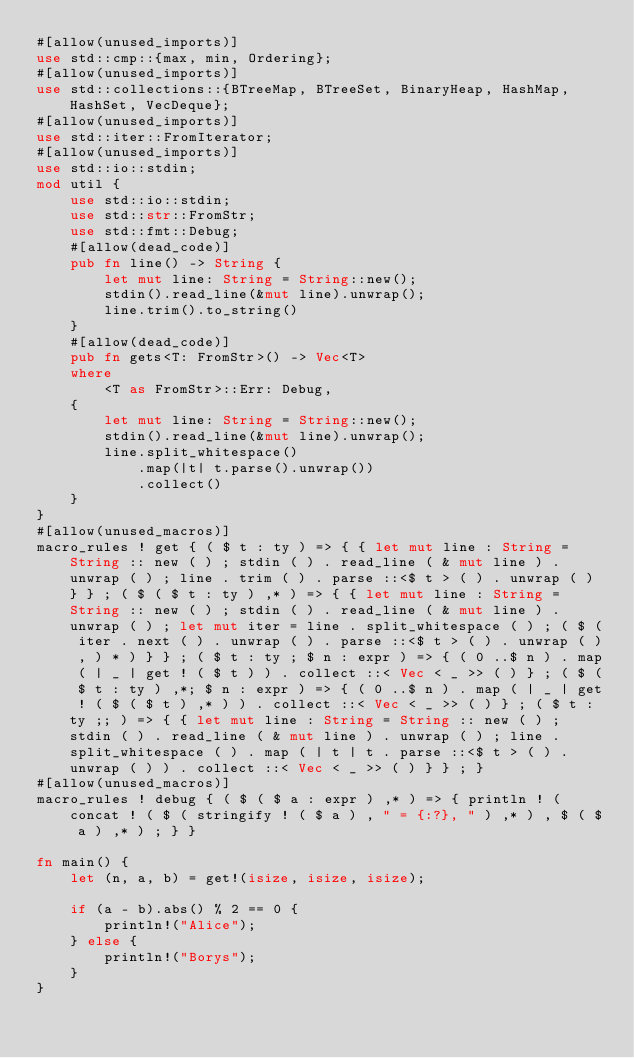Convert code to text. <code><loc_0><loc_0><loc_500><loc_500><_Rust_>#[allow(unused_imports)]
use std::cmp::{max, min, Ordering};
#[allow(unused_imports)]
use std::collections::{BTreeMap, BTreeSet, BinaryHeap, HashMap, HashSet, VecDeque};
#[allow(unused_imports)]
use std::iter::FromIterator;
#[allow(unused_imports)]
use std::io::stdin;
mod util {
    use std::io::stdin;
    use std::str::FromStr;
    use std::fmt::Debug;
    #[allow(dead_code)]
    pub fn line() -> String {
        let mut line: String = String::new();
        stdin().read_line(&mut line).unwrap();
        line.trim().to_string()
    }
    #[allow(dead_code)]
    pub fn gets<T: FromStr>() -> Vec<T>
    where
        <T as FromStr>::Err: Debug,
    {
        let mut line: String = String::new();
        stdin().read_line(&mut line).unwrap();
        line.split_whitespace()
            .map(|t| t.parse().unwrap())
            .collect()
    }
}
#[allow(unused_macros)]
macro_rules ! get { ( $ t : ty ) => { { let mut line : String = String :: new ( ) ; stdin ( ) . read_line ( & mut line ) . unwrap ( ) ; line . trim ( ) . parse ::<$ t > ( ) . unwrap ( ) } } ; ( $ ( $ t : ty ) ,* ) => { { let mut line : String = String :: new ( ) ; stdin ( ) . read_line ( & mut line ) . unwrap ( ) ; let mut iter = line . split_whitespace ( ) ; ( $ ( iter . next ( ) . unwrap ( ) . parse ::<$ t > ( ) . unwrap ( ) , ) * ) } } ; ( $ t : ty ; $ n : expr ) => { ( 0 ..$ n ) . map ( | _ | get ! ( $ t ) ) . collect ::< Vec < _ >> ( ) } ; ( $ ( $ t : ty ) ,*; $ n : expr ) => { ( 0 ..$ n ) . map ( | _ | get ! ( $ ( $ t ) ,* ) ) . collect ::< Vec < _ >> ( ) } ; ( $ t : ty ;; ) => { { let mut line : String = String :: new ( ) ; stdin ( ) . read_line ( & mut line ) . unwrap ( ) ; line . split_whitespace ( ) . map ( | t | t . parse ::<$ t > ( ) . unwrap ( ) ) . collect ::< Vec < _ >> ( ) } } ; }
#[allow(unused_macros)]
macro_rules ! debug { ( $ ( $ a : expr ) ,* ) => { println ! ( concat ! ( $ ( stringify ! ( $ a ) , " = {:?}, " ) ,* ) , $ ( $ a ) ,* ) ; } }

fn main() {
    let (n, a, b) = get!(isize, isize, isize);

    if (a - b).abs() % 2 == 0 {
        println!("Alice");
    } else {
        println!("Borys");
    }
}
</code> 